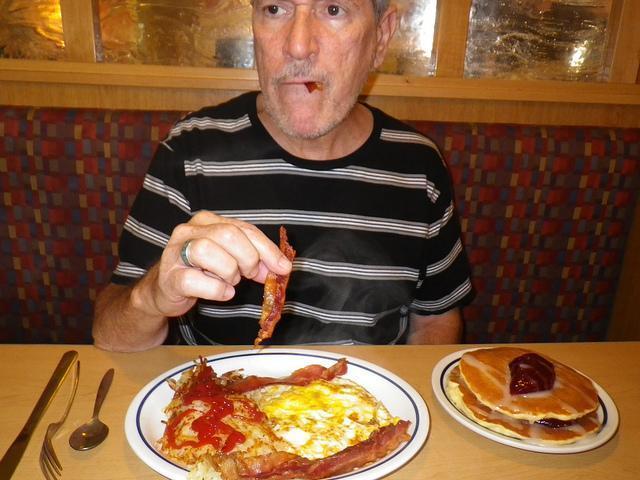How many forks are there?
Give a very brief answer. 1. How many pizzas are there?
Give a very brief answer. 2. How many boats are there?
Give a very brief answer. 0. 